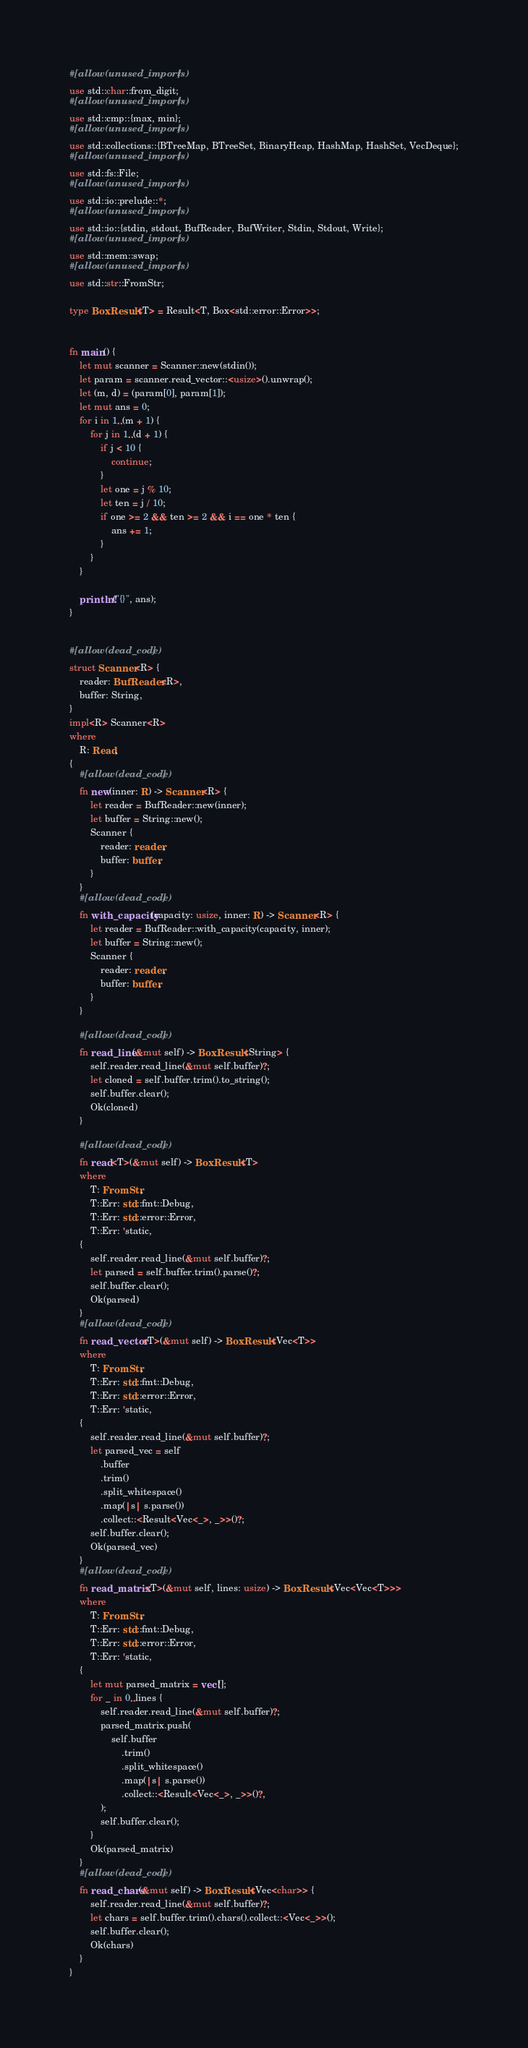<code> <loc_0><loc_0><loc_500><loc_500><_Rust_>#[allow(unused_imports)]
use std::char::from_digit;
#[allow(unused_imports)]
use std::cmp::{max, min};
#[allow(unused_imports)]
use std::collections::{BTreeMap, BTreeSet, BinaryHeap, HashMap, HashSet, VecDeque};
#[allow(unused_imports)]
use std::fs::File;
#[allow(unused_imports)]
use std::io::prelude::*;
#[allow(unused_imports)]
use std::io::{stdin, stdout, BufReader, BufWriter, Stdin, Stdout, Write};
#[allow(unused_imports)]
use std::mem::swap;
#[allow(unused_imports)]
use std::str::FromStr;

type BoxResult<T> = Result<T, Box<std::error::Error>>;


fn main() {
    let mut scanner = Scanner::new(stdin());
    let param = scanner.read_vector::<usize>().unwrap();
    let (m, d) = (param[0], param[1]);
    let mut ans = 0;
    for i in 1..(m + 1) {
        for j in 1..(d + 1) {
            if j < 10 {
                continue;
            }
            let one = j % 10;
            let ten = j / 10;
            if one >= 2 && ten >= 2 && i == one * ten {
                ans += 1;
            }
        }
    }

    println!("{}", ans);
}


#[allow(dead_code)]
struct Scanner<R> {
    reader: BufReader<R>,
    buffer: String,
}
impl<R> Scanner<R>
where
    R: Read,
{
    #[allow(dead_code)]
    fn new(inner: R) -> Scanner<R> {
        let reader = BufReader::new(inner);
        let buffer = String::new();
        Scanner {
            reader: reader,
            buffer: buffer,
        }
    }
    #[allow(dead_code)]
    fn with_capacity(capacity: usize, inner: R) -> Scanner<R> {
        let reader = BufReader::with_capacity(capacity, inner);
        let buffer = String::new();
        Scanner {
            reader: reader,
            buffer: buffer,
        }
    }

    #[allow(dead_code)]
    fn read_line(&mut self) -> BoxResult<String> {
        self.reader.read_line(&mut self.buffer)?;
        let cloned = self.buffer.trim().to_string();
        self.buffer.clear();
        Ok(cloned)
    }

    #[allow(dead_code)]
    fn read<T>(&mut self) -> BoxResult<T>
    where
        T: FromStr,
        T::Err: std::fmt::Debug,
        T::Err: std::error::Error,
        T::Err: 'static,
    {
        self.reader.read_line(&mut self.buffer)?;
        let parsed = self.buffer.trim().parse()?;
        self.buffer.clear();
        Ok(parsed)
    }
    #[allow(dead_code)]
    fn read_vector<T>(&mut self) -> BoxResult<Vec<T>>
    where
        T: FromStr,
        T::Err: std::fmt::Debug,
        T::Err: std::error::Error,
        T::Err: 'static,
    {
        self.reader.read_line(&mut self.buffer)?;
        let parsed_vec = self
            .buffer
            .trim()
            .split_whitespace()
            .map(|s| s.parse())
            .collect::<Result<Vec<_>, _>>()?;
        self.buffer.clear();
        Ok(parsed_vec)
    }
    #[allow(dead_code)]
    fn read_matrix<T>(&mut self, lines: usize) -> BoxResult<Vec<Vec<T>>>
    where
        T: FromStr,
        T::Err: std::fmt::Debug,
        T::Err: std::error::Error,
        T::Err: 'static,
    {
        let mut parsed_matrix = vec![];
        for _ in 0..lines {
            self.reader.read_line(&mut self.buffer)?;
            parsed_matrix.push(
                self.buffer
                    .trim()
                    .split_whitespace()
                    .map(|s| s.parse())
                    .collect::<Result<Vec<_>, _>>()?,
            );
            self.buffer.clear();
        }
        Ok(parsed_matrix)
    }
    #[allow(dead_code)]
    fn read_chars(&mut self) -> BoxResult<Vec<char>> {
        self.reader.read_line(&mut self.buffer)?;
        let chars = self.buffer.trim().chars().collect::<Vec<_>>();
        self.buffer.clear();
        Ok(chars)
    }
}
</code> 